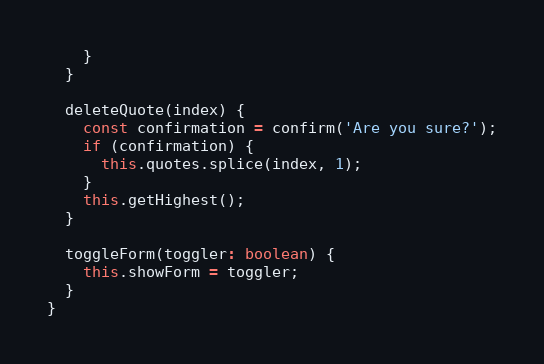<code> <loc_0><loc_0><loc_500><loc_500><_TypeScript_>    }
  }

  deleteQuote(index) {
    const confirmation = confirm('Are you sure?');
    if (confirmation) {
      this.quotes.splice(index, 1);
    }
    this.getHighest();
  }

  toggleForm(toggler: boolean) {
    this.showForm = toggler;
  }
}
</code> 